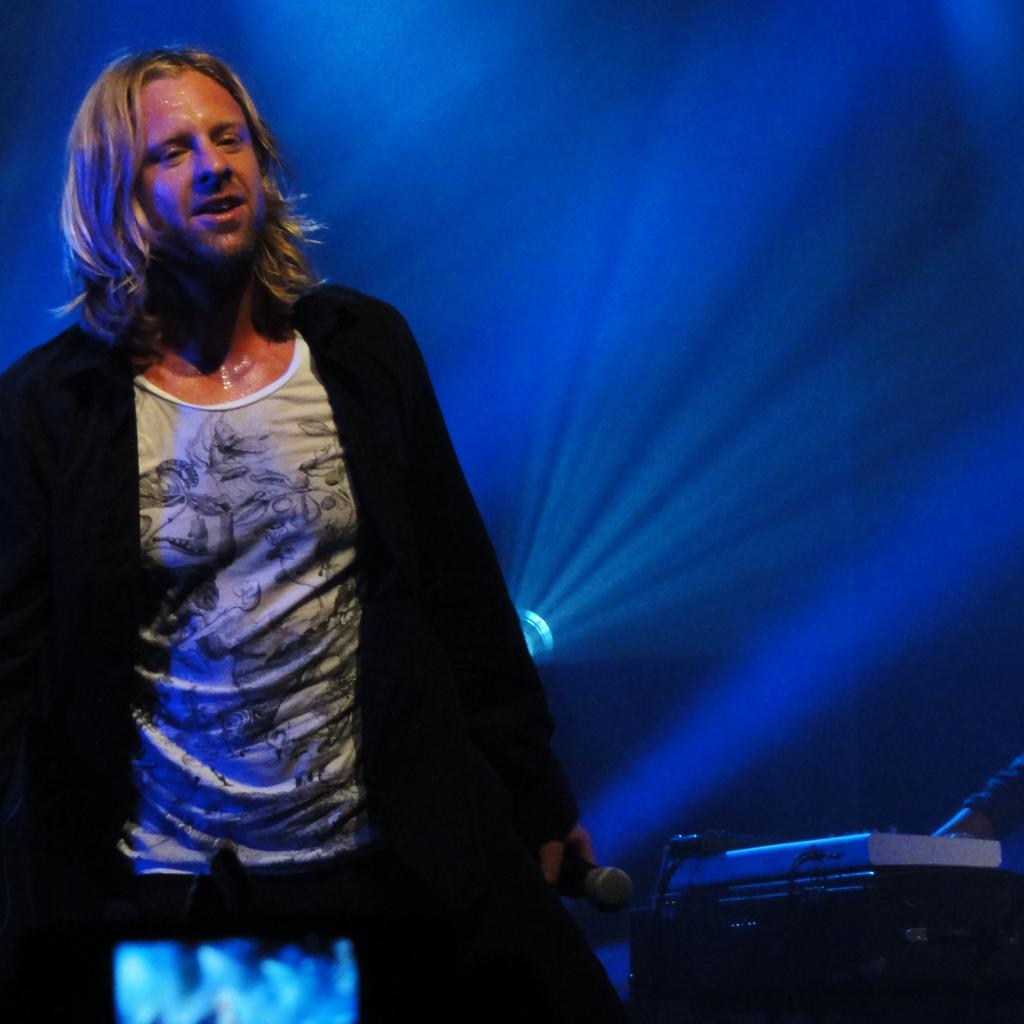What is the person in the image doing? The person is standing in the image and holding a mic. What is the person wearing? The person is wearing a black coat. What else can be seen in the image besides the person? There are musical instruments visible in the image. What type of lighting is present in the image? There is blue color light in the image. What type of meat is being cooked in the pot in the image? There is no pot or meat present in the image. Can you tell me how the person is swimming in the image? There is no swimming activity depicted in the image; the person is standing and holding a mic. 